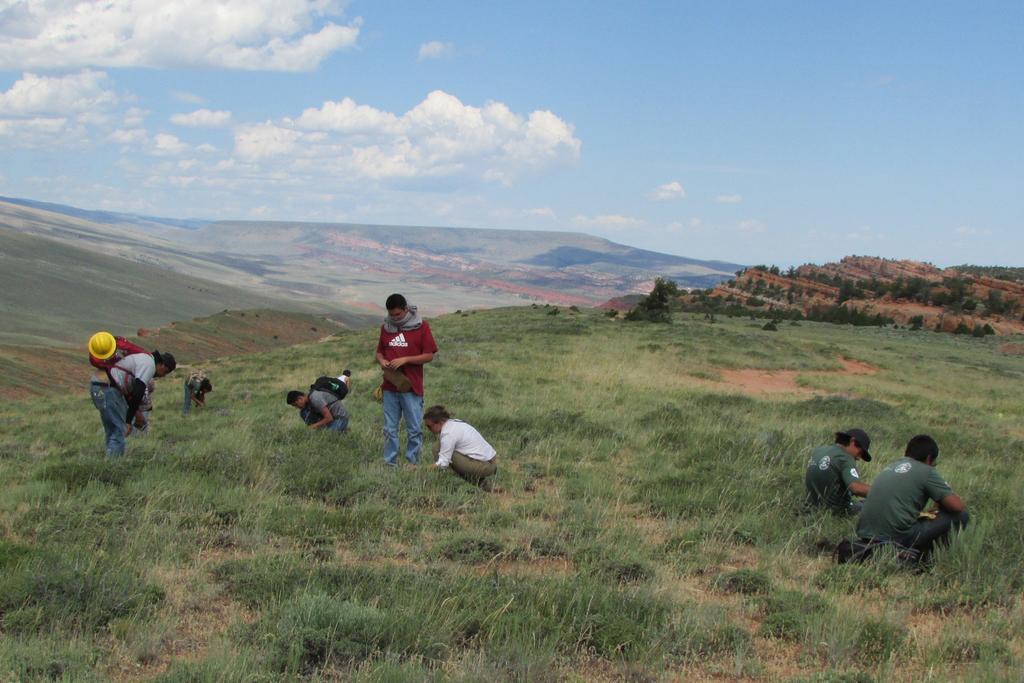Could you give a brief overview of what you see in this image? In the background we can see the clouds in the sky. In this picture we can see the hills and the thicket. In this picture we can see the people and few are in a squat position. A man is standing and another person is wearing yellow helmet. On the right side of the picture we can see the trees. At the bottom portion of the picture we can see the green grass. 